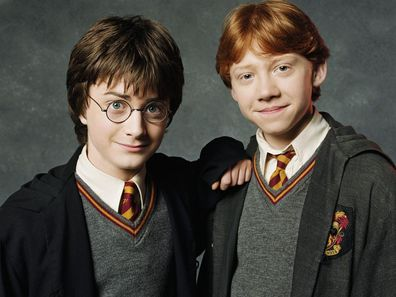If Harry and Ron could interact with a character from another universe, who would it be and why? What if Harry Potter and Ron Weasley could meet Luke Skywalker from the Star Wars universe? The trio could discuss their journeys as young heroes fighting against the forces of darkness. Harry and Ron could share their experiences battling Voldemort, while Luke recounts his battles against the Sith and the Galactic Empire. They might even trade tips on lightsaber duels versus wand duels, and Ron could be fascinated by the concept of The Force and how it connects all living things. The meeting would blend the magic of Hogwarts with the mystical aura of the Force, creating an epic crossover of two legendary worlds. 